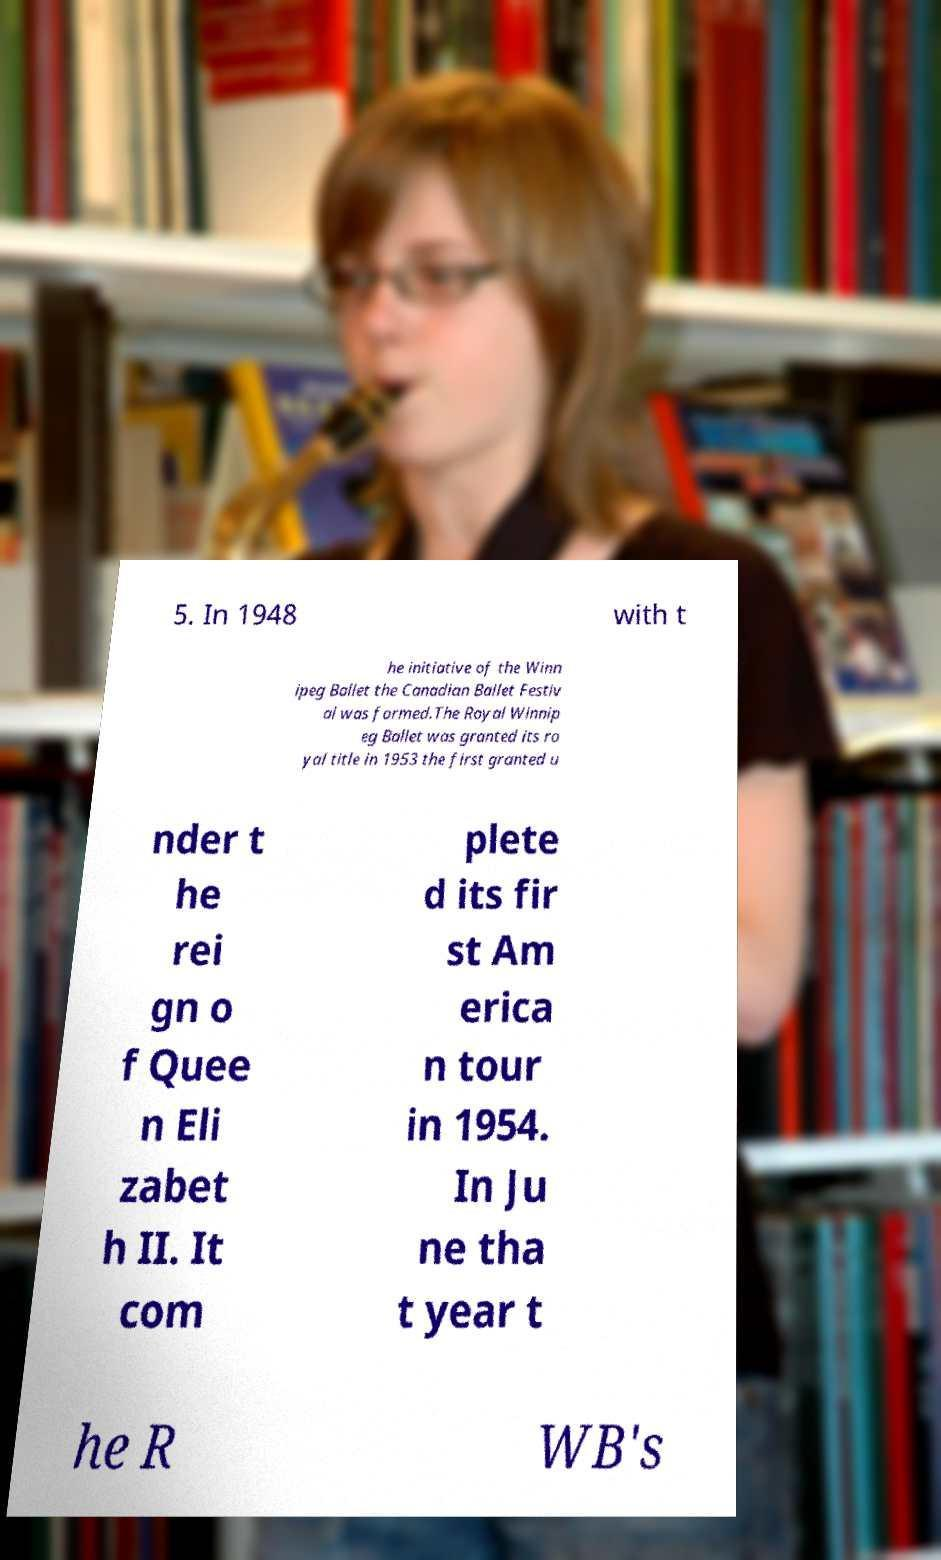There's text embedded in this image that I need extracted. Can you transcribe it verbatim? 5. In 1948 with t he initiative of the Winn ipeg Ballet the Canadian Ballet Festiv al was formed.The Royal Winnip eg Ballet was granted its ro yal title in 1953 the first granted u nder t he rei gn o f Quee n Eli zabet h II. It com plete d its fir st Am erica n tour in 1954. In Ju ne tha t year t he R WB's 